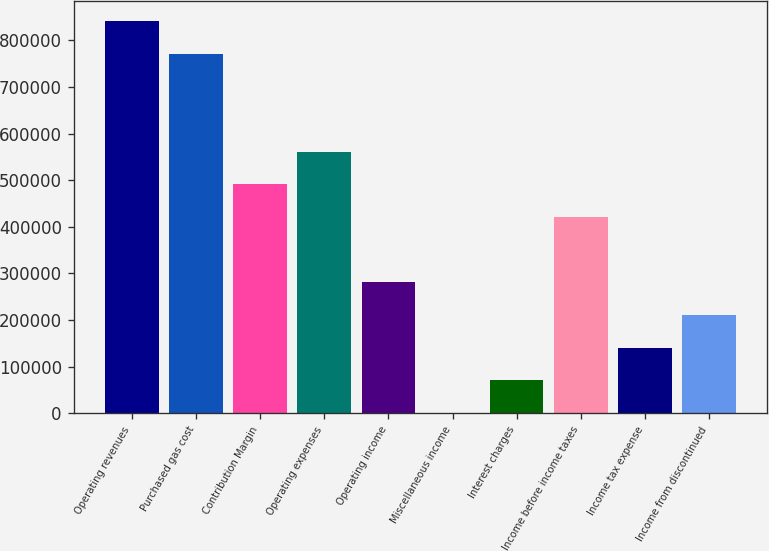Convert chart to OTSL. <chart><loc_0><loc_0><loc_500><loc_500><bar_chart><fcel>Operating revenues<fcel>Purchased gas cost<fcel>Contribution Margin<fcel>Operating expenses<fcel>Operating income<fcel>Miscellaneous income<fcel>Interest charges<fcel>Income before income taxes<fcel>Income tax expense<fcel>Income from discontinued<nl><fcel>841923<fcel>771770<fcel>491155<fcel>561309<fcel>280694<fcel>79<fcel>70232.7<fcel>421001<fcel>140386<fcel>210540<nl></chart> 